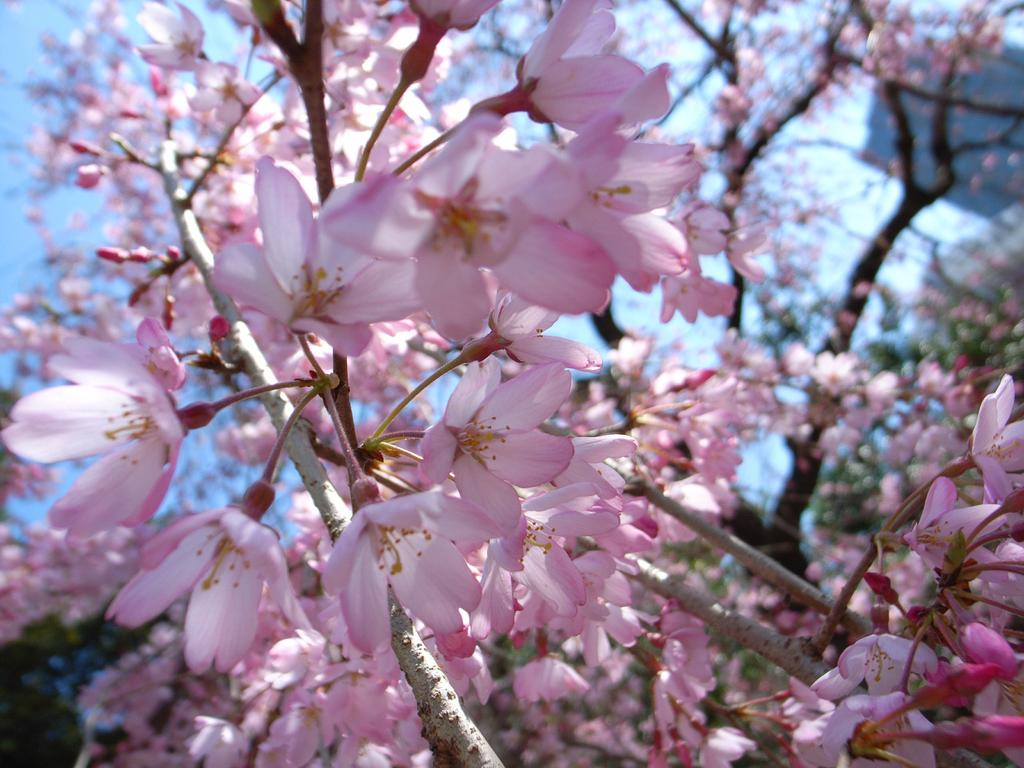What type of vegetation can be seen in the image? There are trees in the image. What other natural elements are present in the image? There are flowers in the image. What is visible in the background of the image? The sky is visible in the image. What can be seen on the right side of the image? There are objects on the right side of the image. What color is the sweater worn by the person in the image? There is no person wearing a sweater in the image; it primarily features natural elements such as trees, flowers, and the sky. 